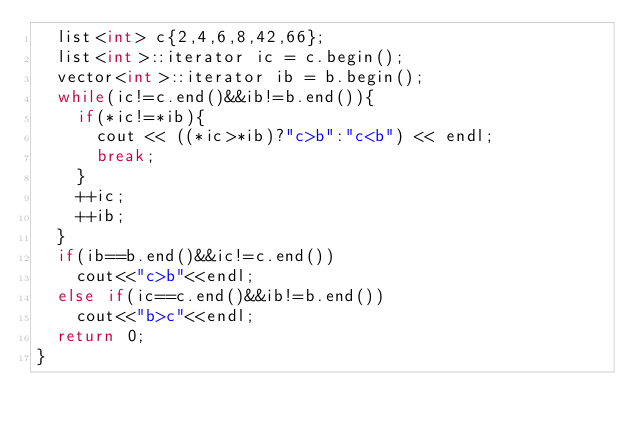<code> <loc_0><loc_0><loc_500><loc_500><_C++_>	list<int> c{2,4,6,8,42,66};
	list<int>::iterator ic = c.begin();
	vector<int>::iterator ib = b.begin();
	while(ic!=c.end()&&ib!=b.end()){
		if(*ic!=*ib){
			cout << ((*ic>*ib)?"c>b":"c<b") << endl;
			break;
		}
		++ic;
		++ib;
	}
	if(ib==b.end()&&ic!=c.end())
		cout<<"c>b"<<endl;
	else if(ic==c.end()&&ib!=b.end())
		cout<<"b>c"<<endl;
	return 0;
}


</code> 